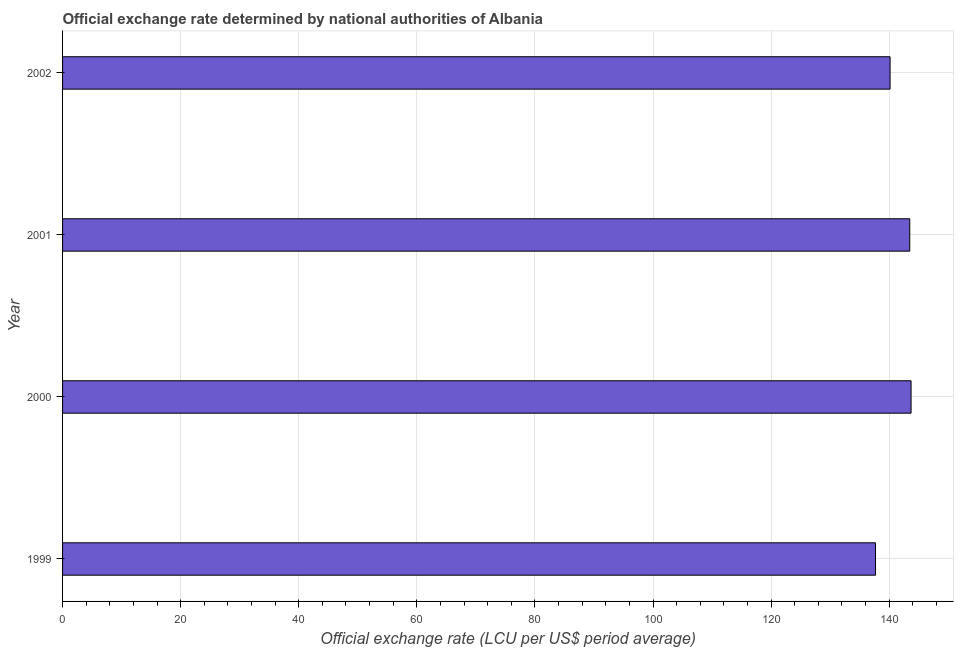Does the graph contain grids?
Offer a terse response. Yes. What is the title of the graph?
Keep it short and to the point. Official exchange rate determined by national authorities of Albania. What is the label or title of the X-axis?
Ensure brevity in your answer.  Official exchange rate (LCU per US$ period average). What is the official exchange rate in 2000?
Give a very brief answer. 143.71. Across all years, what is the maximum official exchange rate?
Keep it short and to the point. 143.71. Across all years, what is the minimum official exchange rate?
Make the answer very short. 137.69. In which year was the official exchange rate minimum?
Your response must be concise. 1999. What is the sum of the official exchange rate?
Ensure brevity in your answer.  565.04. What is the difference between the official exchange rate in 1999 and 2001?
Offer a very short reply. -5.79. What is the average official exchange rate per year?
Ensure brevity in your answer.  141.26. What is the median official exchange rate?
Ensure brevity in your answer.  141.82. Do a majority of the years between 1999 and 2001 (inclusive) have official exchange rate greater than 32 ?
Offer a very short reply. Yes. Is the official exchange rate in 2000 less than that in 2002?
Your response must be concise. No. What is the difference between the highest and the second highest official exchange rate?
Your answer should be compact. 0.23. Is the sum of the official exchange rate in 1999 and 2002 greater than the maximum official exchange rate across all years?
Ensure brevity in your answer.  Yes. What is the difference between the highest and the lowest official exchange rate?
Your answer should be very brief. 6.02. How many bars are there?
Ensure brevity in your answer.  4. How many years are there in the graph?
Give a very brief answer. 4. Are the values on the major ticks of X-axis written in scientific E-notation?
Keep it short and to the point. No. What is the Official exchange rate (LCU per US$ period average) of 1999?
Ensure brevity in your answer.  137.69. What is the Official exchange rate (LCU per US$ period average) of 2000?
Make the answer very short. 143.71. What is the Official exchange rate (LCU per US$ period average) of 2001?
Your answer should be compact. 143.48. What is the Official exchange rate (LCU per US$ period average) of 2002?
Ensure brevity in your answer.  140.15. What is the difference between the Official exchange rate (LCU per US$ period average) in 1999 and 2000?
Your answer should be compact. -6.02. What is the difference between the Official exchange rate (LCU per US$ period average) in 1999 and 2001?
Give a very brief answer. -5.79. What is the difference between the Official exchange rate (LCU per US$ period average) in 1999 and 2002?
Offer a terse response. -2.46. What is the difference between the Official exchange rate (LCU per US$ period average) in 2000 and 2001?
Offer a terse response. 0.22. What is the difference between the Official exchange rate (LCU per US$ period average) in 2000 and 2002?
Your answer should be compact. 3.55. What is the difference between the Official exchange rate (LCU per US$ period average) in 2001 and 2002?
Give a very brief answer. 3.33. What is the ratio of the Official exchange rate (LCU per US$ period average) in 1999 to that in 2000?
Ensure brevity in your answer.  0.96. What is the ratio of the Official exchange rate (LCU per US$ period average) in 1999 to that in 2002?
Provide a succinct answer. 0.98. 